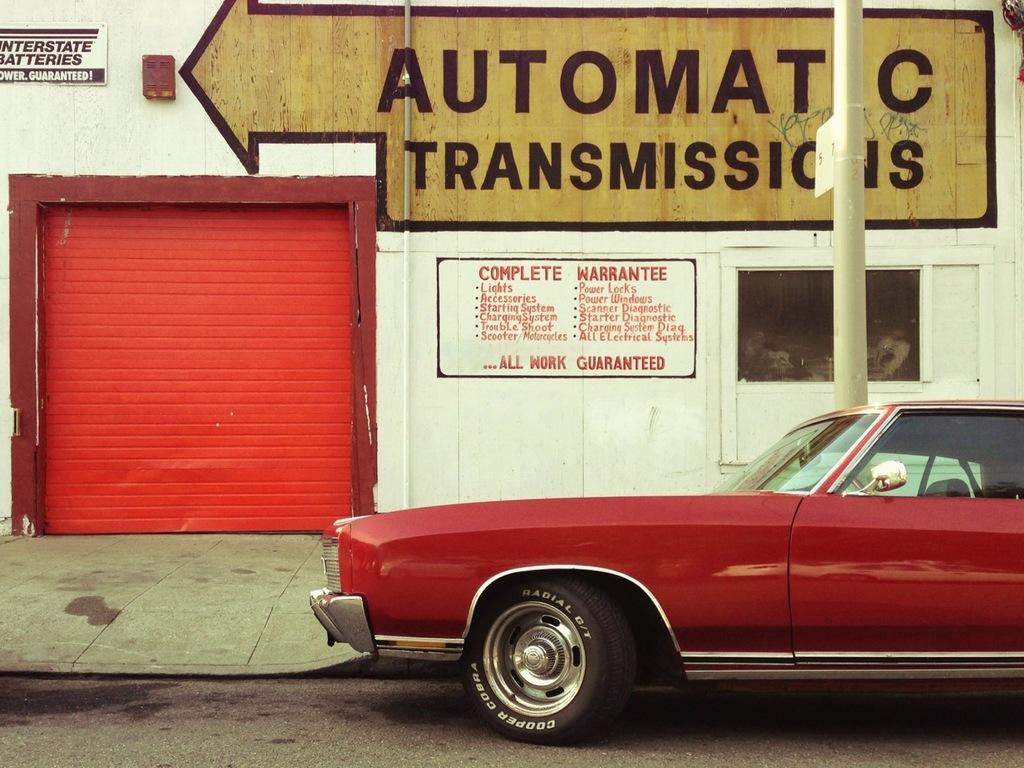What is the main subject of the image? There is a car in the image. Where is the car located in relation to the road? The car is parked beside the road. What other objects can be seen in the image? There is a shutter, a pole, a board, and written text on a wall visible in the image. How many jellyfish are swimming in the car in the image? There are no jellyfish present in the image, as it features a car parked beside the road and other objects. What nation is represented by the board in the image? The provided facts do not mention any specific nation or board representing a nation, so it cannot be determined from the image. 